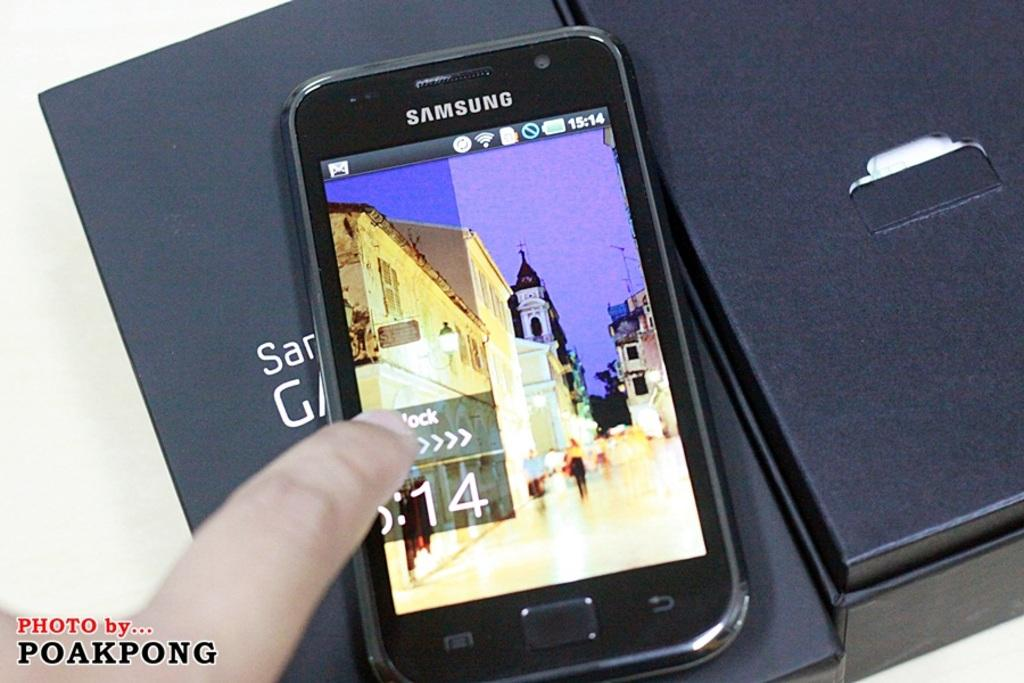<image>
Write a terse but informative summary of the picture. a Samsung phone on a black background taken by Poakpong 